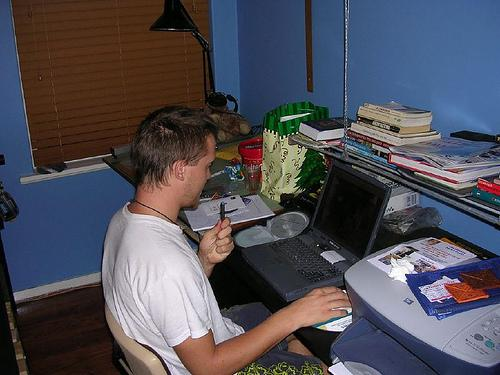What is he doing? recording voice 